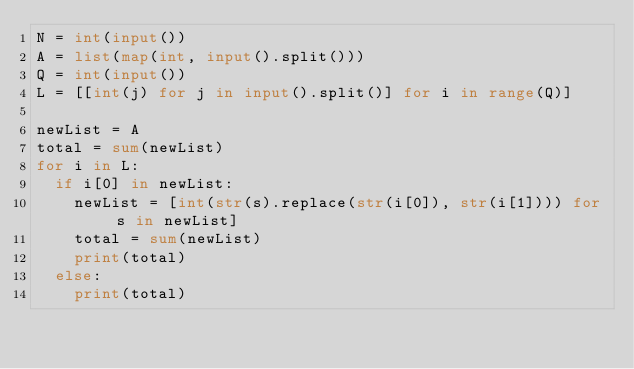Convert code to text. <code><loc_0><loc_0><loc_500><loc_500><_Python_>N = int(input())
A = list(map(int, input().split()))
Q = int(input())
L = [[int(j) for j in input().split()] for i in range(Q)]

newList = A
total = sum(newList)
for i in L:
  if i[0] in newList:
    newList = [int(str(s).replace(str(i[0]), str(i[1]))) for s in newList]
    total = sum(newList)
    print(total)
  else:
    print(total)</code> 